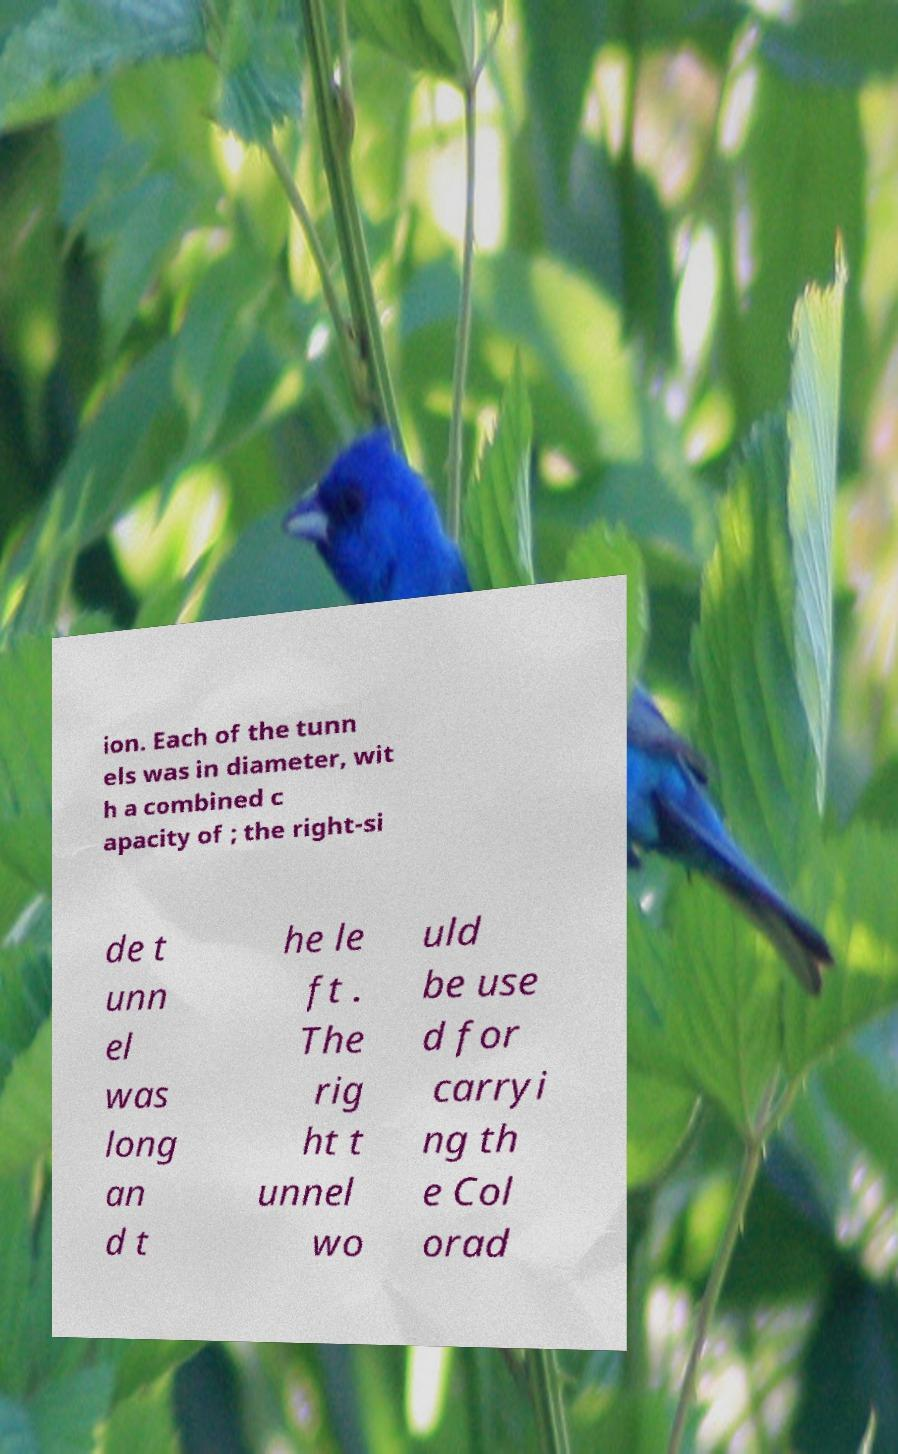Please read and relay the text visible in this image. What does it say? ion. Each of the tunn els was in diameter, wit h a combined c apacity of ; the right-si de t unn el was long an d t he le ft . The rig ht t unnel wo uld be use d for carryi ng th e Col orad 